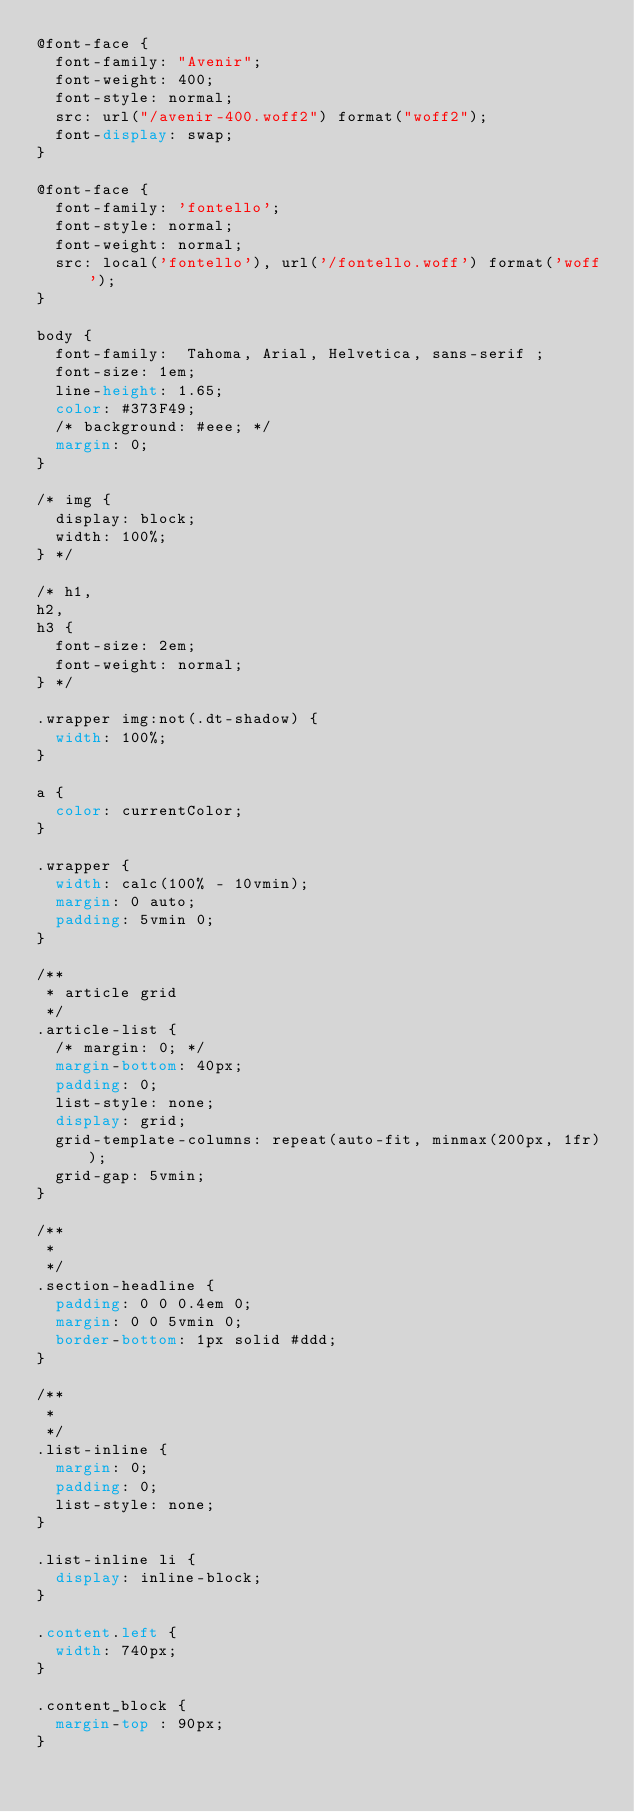Convert code to text. <code><loc_0><loc_0><loc_500><loc_500><_CSS_>@font-face {
  font-family: "Avenir";
  font-weight: 400;
  font-style: normal;
  src: url("/avenir-400.woff2") format("woff2");
  font-display: swap;
}

@font-face {
  font-family: 'fontello';
  font-style: normal;
  font-weight: normal;
  src: local('fontello'), url('/fontello.woff') format('woff');
}

body {
  font-family:  Tahoma, Arial, Helvetica, sans-serif ;
  font-size: 1em;
  line-height: 1.65;
  color: #373F49;
  /* background: #eee; */
  margin: 0;
}

/* img {
  display: block;
  width: 100%;
} */

/* h1,
h2,
h3 {
  font-size: 2em;
  font-weight: normal;
} */

.wrapper img:not(.dt-shadow) {
  width: 100%;
}

a {
  color: currentColor;
}

.wrapper {
  width: calc(100% - 10vmin);
  margin: 0 auto;
  padding: 5vmin 0;
}

/**
 * article grid
 */
.article-list {
  /* margin: 0; */
  margin-bottom: 40px;
  padding: 0;
  list-style: none;
  display: grid;
  grid-template-columns: repeat(auto-fit, minmax(200px, 1fr));
  grid-gap: 5vmin;
}

/**
 *
 */
.section-headline {
  padding: 0 0 0.4em 0;
  margin: 0 0 5vmin 0;
  border-bottom: 1px solid #ddd;
}

/**
 *
 */
.list-inline {
  margin: 0;
  padding: 0;
  list-style: none;
}

.list-inline li {
  display: inline-block;
}

.content.left {
  width: 740px;
}

.content_block {
  margin-top : 90px;
}
























</code> 